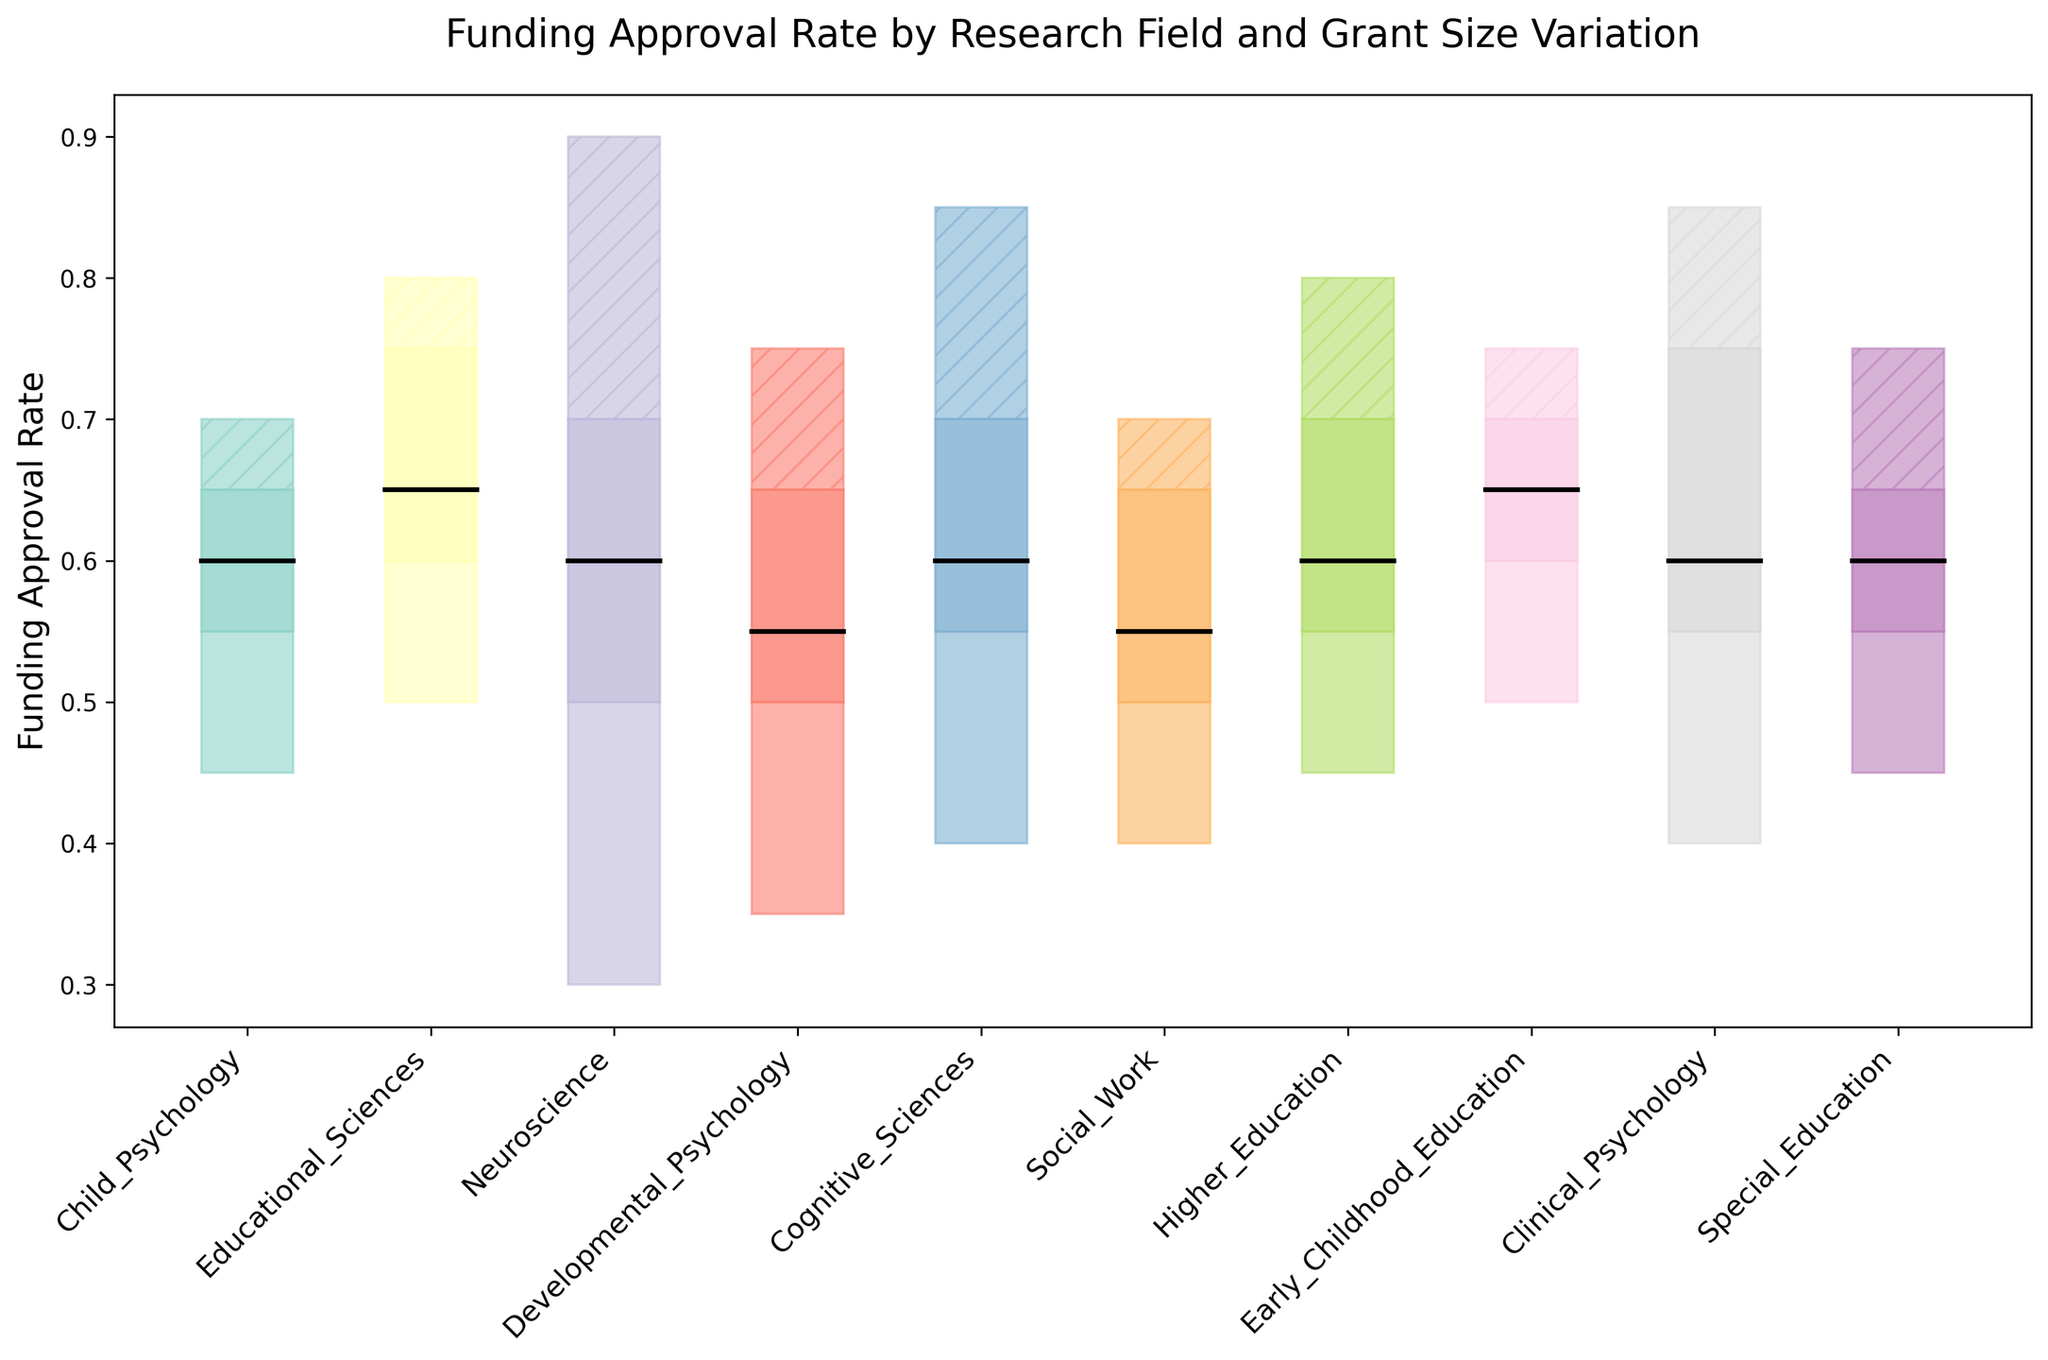What's the median funding approval rate for Educational Sciences? Look at the "Educational Sciences" row and identify the median value, which is visually marked by the line inside the IQR box. The median value for Educational Sciences is 0.65.
Answer: 0.65 Which research field has the highest third quartile in funding approval rates? Identify the highest third quartile value among all the fields. Child Psychology has a third quartile at 0.65, Educational Sciences at 0.75, Neuroscience at 0.7, Developmental Psychology at 0.65, and so on. The highest third quartile is in Educational Sciences and Clinical Psychology, both at 0.75.
Answer: Educational Sciences and Clinical Psychology What is the range of funding approval rates for Neuroscience? Calculate the range by subtracting the minimum value from the maximum value for Neuroscience. The maximum value is 0.9, and the minimum value is 0.3. Therefore, the range is 0.9 - 0.3 = 0.6.
Answer: 0.6 Which research fields have the same median funding approval rate? Identify the median values for each research field and compare them. The median funding approval rate for Child Psychology, Cognitive Sciences, Social Work, Special Education, and Clinical Psychology are all 0.6.
Answer: Child Psychology, Cognitive Sciences, Social Work, Special Education, and Clinical Psychology What is the funding approval rate range between the first and third quartiles for Higher Education? The range between the first and third quartiles is calculated by subtracting the first quartile (0.55) from the third quartile (0.7). Therefore, the range is 0.7 - 0.55 = 0.15.
Answer: 0.15 Which field has the highest minimum funding approval rate? Compare the minimum values for all fields. The highest minimum value is in Early Childhood Education and Educational Sciences, both at 0.5.
Answer: Early Childhood Education and Educational Sciences How does the maximum funding approval rate of Clinical Psychology compare to that of Cognitive Sciences? Compare the maximum values for Clinical Psychology (0.85) and Cognitive Sciences (0.85). Both have the same maximum value of 0.85.
Answer: They are equal What is the interquartile range (IQR) for Developmental Psychology? The IQR is found by subtracting the first quartile from the third quartile. For Developmental Psychology, the third quartile is 0.65, and the first quartile is 0.5. Thus, the IQR is 0.65 - 0.5 = 0.15.
Answer: 0.15 